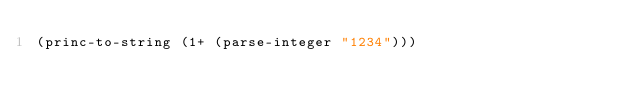<code> <loc_0><loc_0><loc_500><loc_500><_Lisp_>(princ-to-string (1+ (parse-integer "1234")))
</code> 